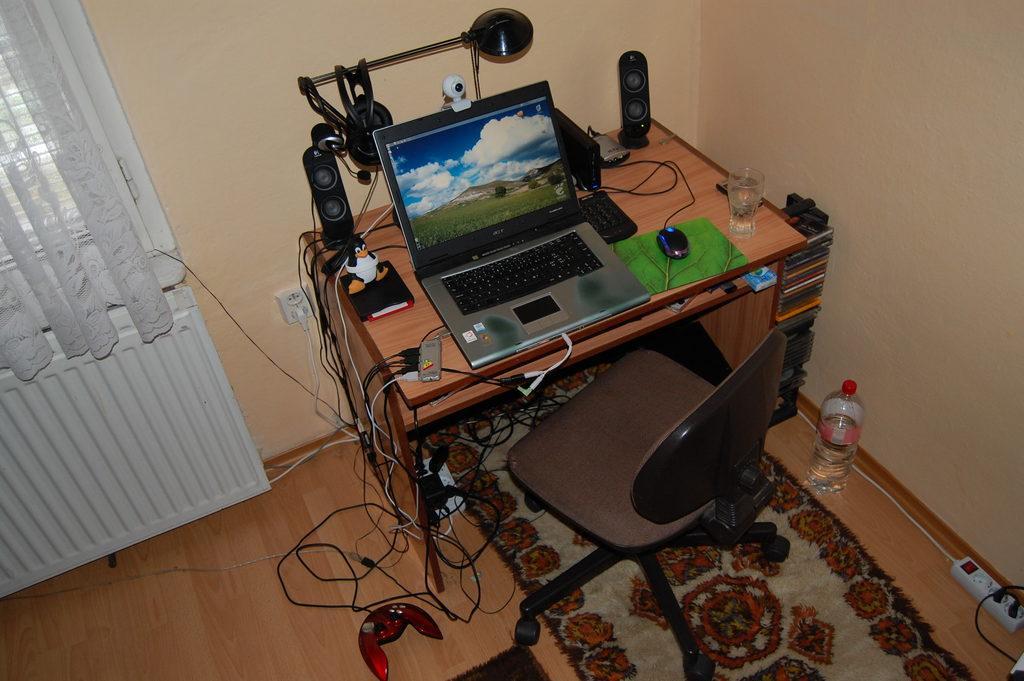Please provide a concise description of this image. In this picture we can see table. On the table we can see laptop,mouse,keyboard,glass,speakers,lamp,camera,book,toy,cable. We can see chair. This is bottle. This is floor. On the background we can see wall and curtain. 